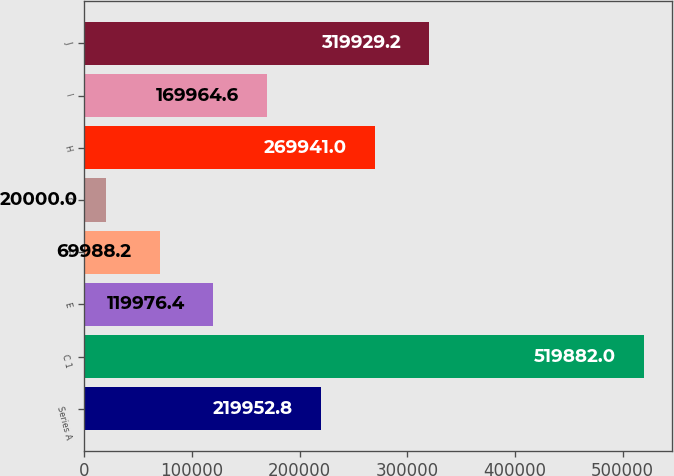<chart> <loc_0><loc_0><loc_500><loc_500><bar_chart><fcel>Series A<fcel>C 1<fcel>E<fcel>F<fcel>G<fcel>H<fcel>I<fcel>J<nl><fcel>219953<fcel>519882<fcel>119976<fcel>69988.2<fcel>20000<fcel>269941<fcel>169965<fcel>319929<nl></chart> 